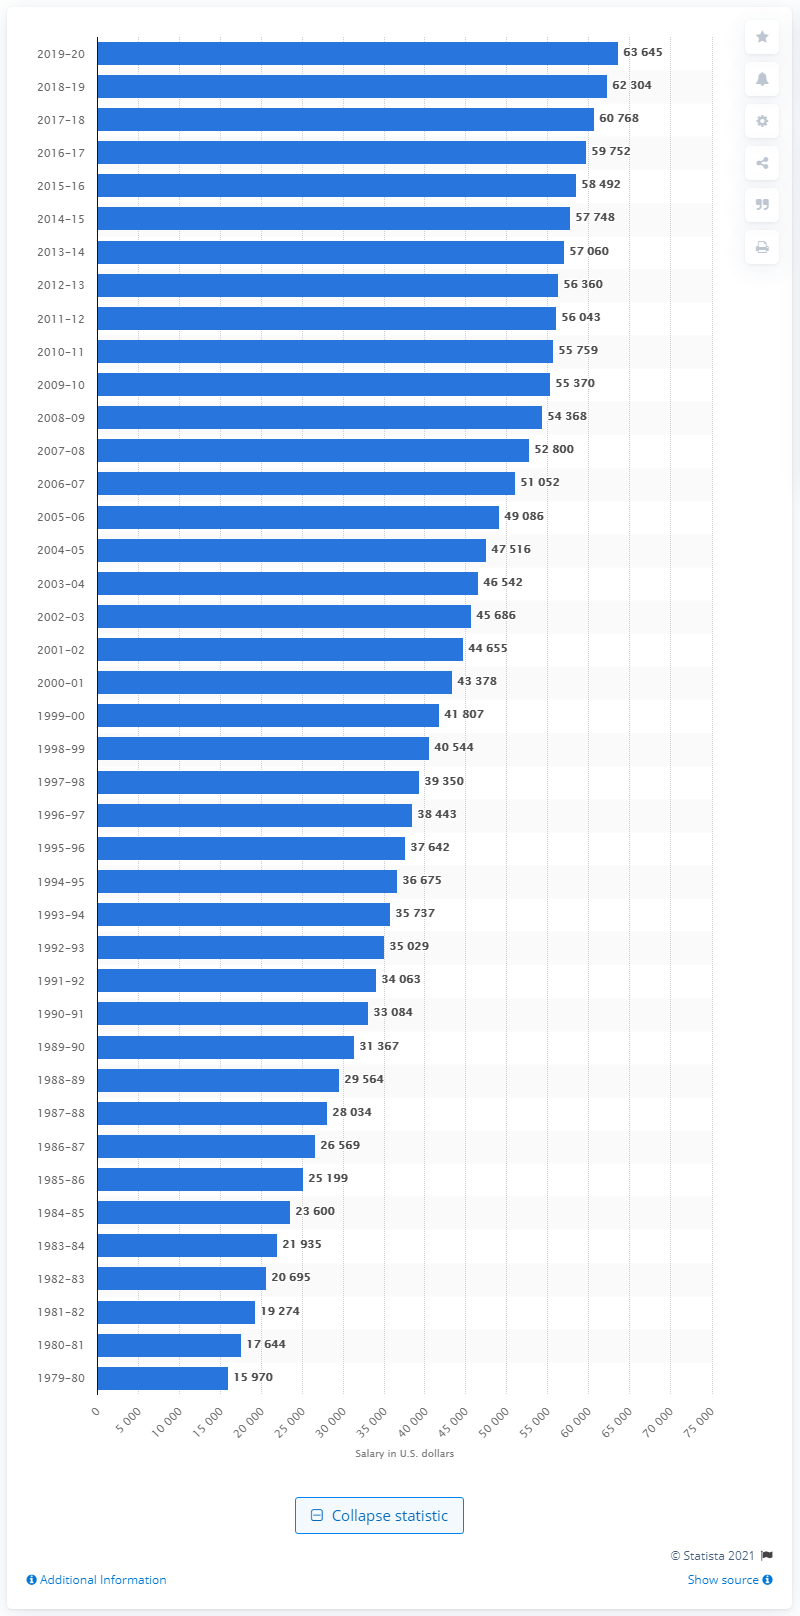Mention a couple of crucial points in this snapshot. The average salary of public school teachers in the United States during the 2019-2020 academic year was approximately 63,645 U.S. dollars. 